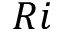Convert formula to latex. <formula><loc_0><loc_0><loc_500><loc_500>R i</formula> 